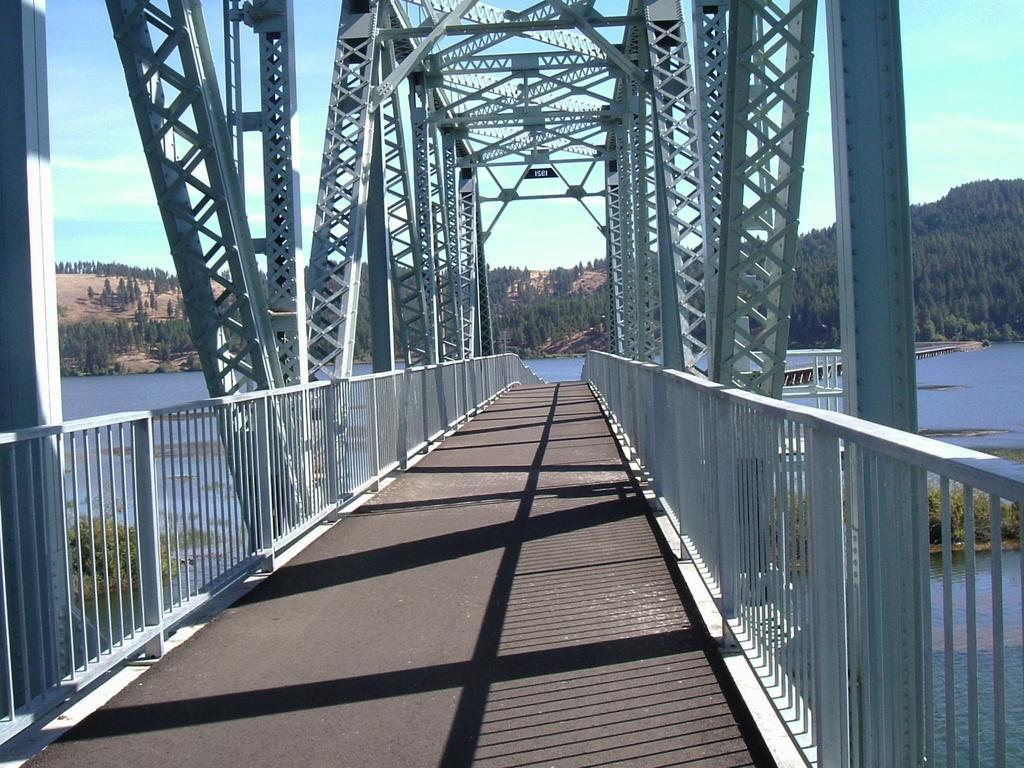In one or two sentences, can you explain what this image depicts? This is a bridge, these are trees, this is water and a sky. 